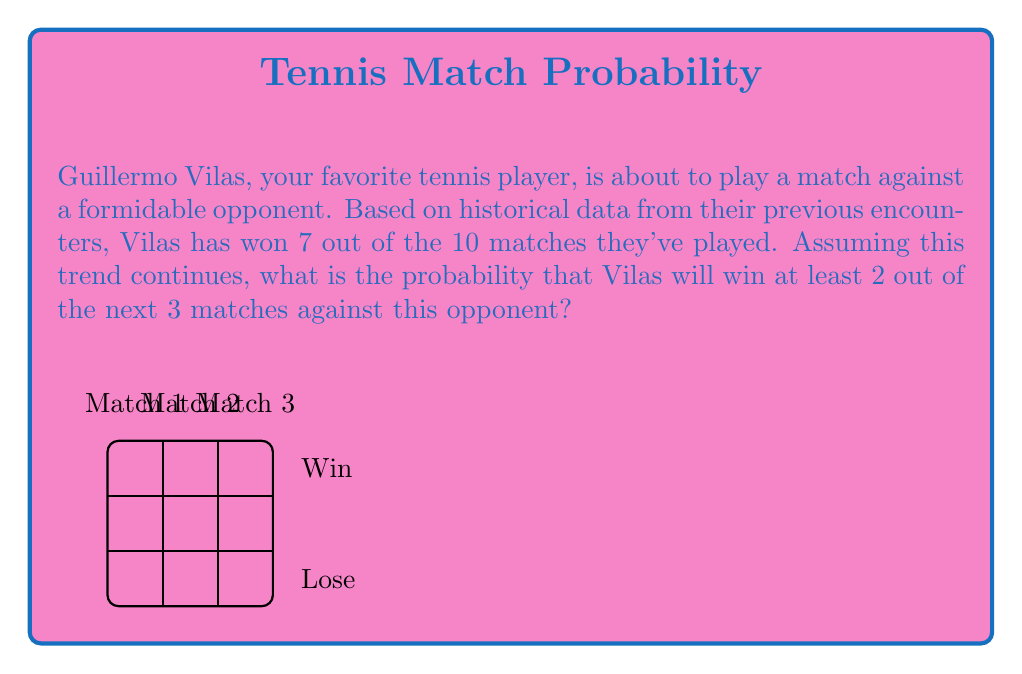Solve this math problem. Let's approach this step-by-step:

1) First, we need to determine the probability of Vilas winning a single match. Based on the historical data:

   $P(\text{Vilas wins}) = \frac{7}{10} = 0.7$

2) Now, we need to calculate the probability of Vilas winning at least 2 out of 3 matches. This can happen in three ways:
   - Vilas wins all 3 matches
   - Vilas wins the first two matches and loses the third
   - Vilas wins the first and third matches but loses the second
   - Vilas loses the first match but wins the second and third

3) Let's calculate the probability of each scenario:

   a) $P(\text{WWW}) = 0.7 \times 0.7 \times 0.7 = 0.343$
   b) $P(\text{WWL}) = 0.7 \times 0.7 \times 0.3 = 0.147$
   c) $P(\text{WLW}) = 0.7 \times 0.3 \times 0.7 = 0.147$
   d) $P(\text{LWW}) = 0.3 \times 0.7 \times 0.7 = 0.147$

4) The total probability is the sum of these individual probabilities:

   $P(\text{at least 2 wins}) = 0.343 + 0.147 + 0.147 + 0.147 = 0.784$

5) We can also calculate this using the binomial probability formula:

   $$P(X \geq 2) = \binom{3}{2}p^2(1-p) + \binom{3}{3}p^3$$

   Where $p = 0.7$ and $X$ is the number of wins.

   $$P(X \geq 2) = 3(0.7)^2(0.3) + (0.7)^3 = 3(0.49)(0.3) + 0.343 = 0.441 + 0.343 = 0.784$$

Therefore, the probability that Guillermo Vilas will win at least 2 out of the next 3 matches is 0.784 or 78.4%.
Answer: 0.784 